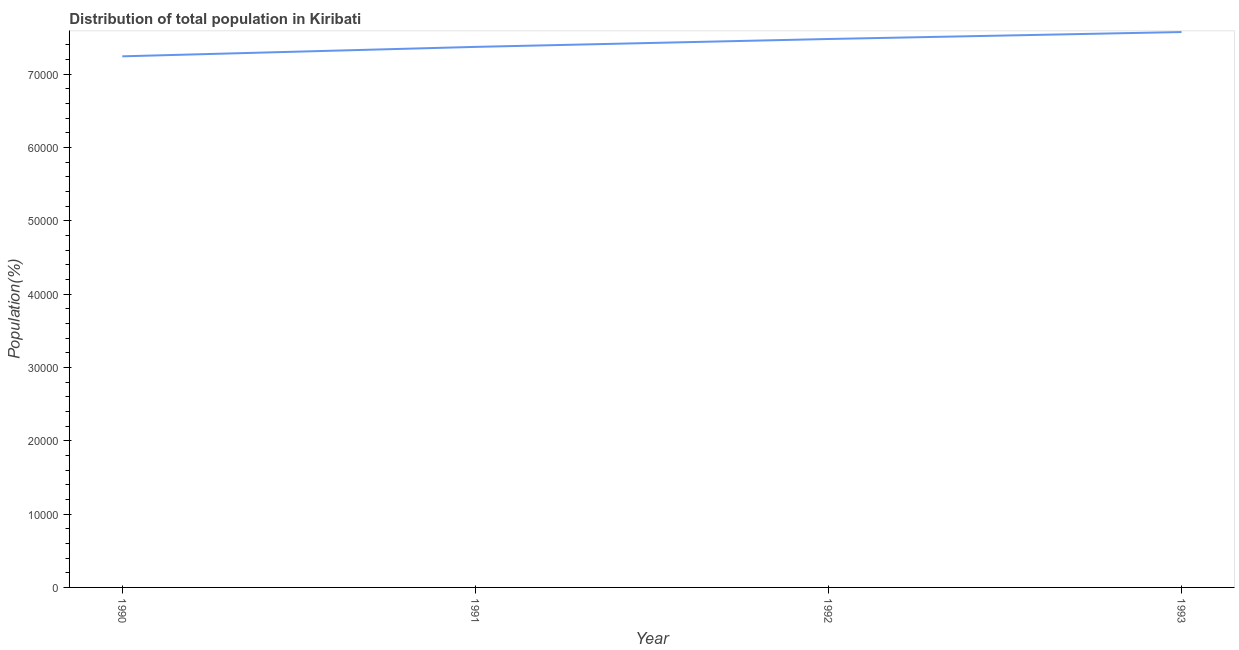What is the population in 1990?
Make the answer very short. 7.24e+04. Across all years, what is the maximum population?
Ensure brevity in your answer.  7.57e+04. Across all years, what is the minimum population?
Provide a short and direct response. 7.24e+04. In which year was the population maximum?
Offer a very short reply. 1993. What is the sum of the population?
Give a very brief answer. 2.97e+05. What is the difference between the population in 1991 and 1993?
Provide a succinct answer. -2024. What is the average population per year?
Offer a very short reply. 7.42e+04. What is the median population?
Give a very brief answer. 7.42e+04. Do a majority of the years between 1990 and 1993 (inclusive) have population greater than 6000 %?
Your response must be concise. Yes. What is the ratio of the population in 1992 to that in 1993?
Provide a short and direct response. 0.99. Is the difference between the population in 1991 and 1993 greater than the difference between any two years?
Keep it short and to the point. No. What is the difference between the highest and the second highest population?
Keep it short and to the point. 949. What is the difference between the highest and the lowest population?
Your answer should be very brief. 3311. Does the population monotonically increase over the years?
Your response must be concise. Yes. Does the graph contain any zero values?
Your response must be concise. No. Does the graph contain grids?
Give a very brief answer. No. What is the title of the graph?
Ensure brevity in your answer.  Distribution of total population in Kiribati . What is the label or title of the X-axis?
Your answer should be very brief. Year. What is the label or title of the Y-axis?
Offer a very short reply. Population(%). What is the Population(%) of 1990?
Make the answer very short. 7.24e+04. What is the Population(%) in 1991?
Provide a short and direct response. 7.37e+04. What is the Population(%) of 1992?
Provide a short and direct response. 7.48e+04. What is the Population(%) of 1993?
Ensure brevity in your answer.  7.57e+04. What is the difference between the Population(%) in 1990 and 1991?
Your answer should be compact. -1287. What is the difference between the Population(%) in 1990 and 1992?
Your answer should be compact. -2362. What is the difference between the Population(%) in 1990 and 1993?
Your answer should be very brief. -3311. What is the difference between the Population(%) in 1991 and 1992?
Your response must be concise. -1075. What is the difference between the Population(%) in 1991 and 1993?
Give a very brief answer. -2024. What is the difference between the Population(%) in 1992 and 1993?
Offer a very short reply. -949. What is the ratio of the Population(%) in 1990 to that in 1991?
Offer a very short reply. 0.98. What is the ratio of the Population(%) in 1990 to that in 1993?
Ensure brevity in your answer.  0.96. What is the ratio of the Population(%) in 1991 to that in 1993?
Provide a succinct answer. 0.97. What is the ratio of the Population(%) in 1992 to that in 1993?
Provide a short and direct response. 0.99. 